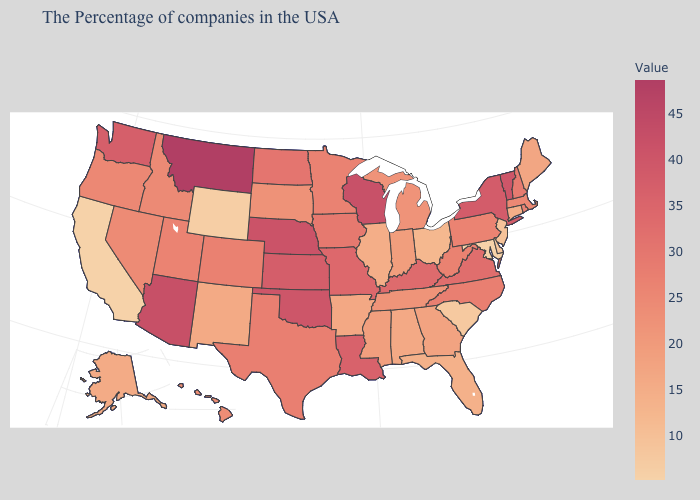Is the legend a continuous bar?
Answer briefly. Yes. Which states have the highest value in the USA?
Concise answer only. Montana. Among the states that border Pennsylvania , does West Virginia have the highest value?
Write a very short answer. No. Which states have the lowest value in the South?
Answer briefly. Maryland. Which states have the lowest value in the USA?
Give a very brief answer. Maryland, California. Does the map have missing data?
Short answer required. No. Does Maryland have the lowest value in the South?
Concise answer only. Yes. Which states hav the highest value in the MidWest?
Quick response, please. Wisconsin. Which states have the lowest value in the USA?
Answer briefly. Maryland, California. 